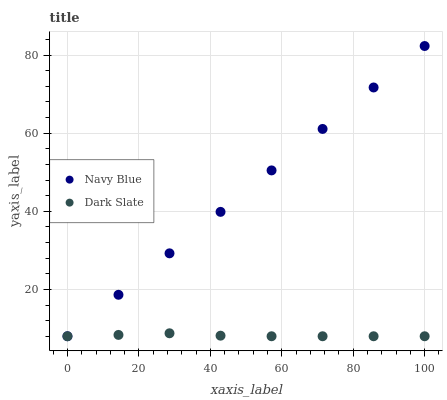Does Dark Slate have the minimum area under the curve?
Answer yes or no. Yes. Does Navy Blue have the maximum area under the curve?
Answer yes or no. Yes. Does Dark Slate have the maximum area under the curve?
Answer yes or no. No. Is Navy Blue the smoothest?
Answer yes or no. Yes. Is Dark Slate the roughest?
Answer yes or no. Yes. Is Dark Slate the smoothest?
Answer yes or no. No. Does Navy Blue have the lowest value?
Answer yes or no. Yes. Does Navy Blue have the highest value?
Answer yes or no. Yes. Does Dark Slate have the highest value?
Answer yes or no. No. Does Dark Slate intersect Navy Blue?
Answer yes or no. Yes. Is Dark Slate less than Navy Blue?
Answer yes or no. No. Is Dark Slate greater than Navy Blue?
Answer yes or no. No. 